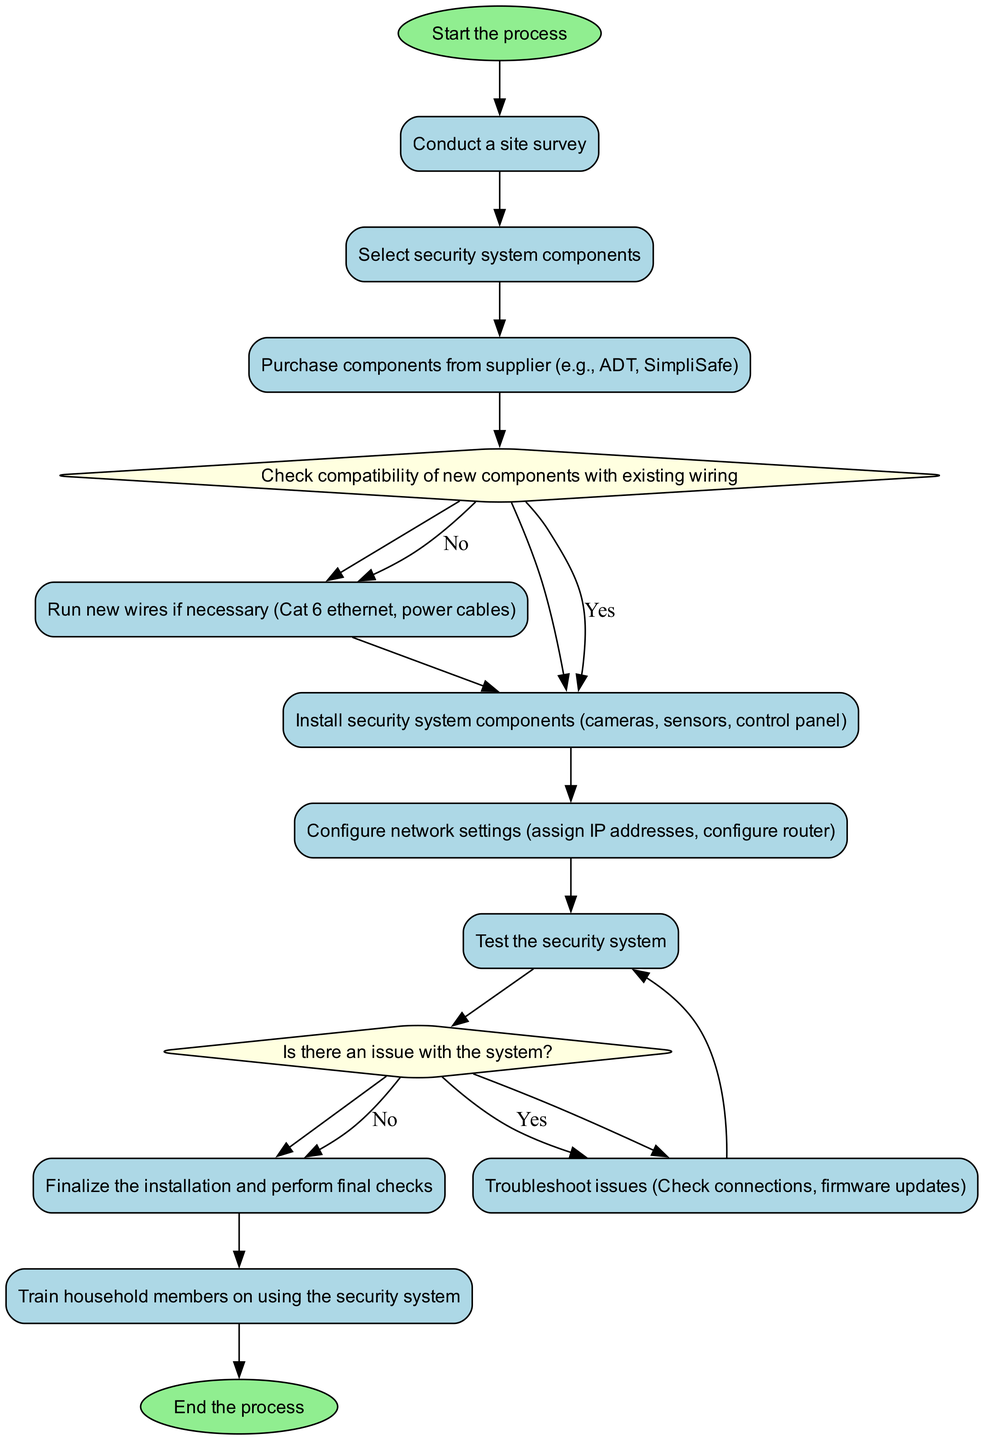What is the starting point of the flowchart? The flowchart begins with the "Start the process" node, labeled as "start". It serves as the entry point to the entire process of purchasing and installing a home security system.
Answer: Start the process How many decision nodes are present in the diagram? The diagram includes two decision nodes: "Check compatibility of new components with existing wiring" and "Is there an issue with the system?" This can be counted by identifying nodes with the type "decision" in the diagram.
Answer: 2 What process follows after the "Test the security system" node? After testing the system, the flowchart leads to the decision node "Is there an issue with the system?" This indicates the next step the user will review based on the testing outcome.
Answer: Is there an issue with the system? Which components are installed in the process? The installation process includes components such as cameras, sensors, and the control panel. This information is derived from the node labeled "Install security system components".
Answer: Cameras, sensors, control panel What action is taken if there is an issue detected with the system? If an issue is detected, the flowchart directs to the "Troubleshoot issues" process. The decision node clearly indicates that troubleshooting follows when problems arise after testing.
Answer: Troubleshoot issues What happens if the new components are compatible? If the new components are compatible with the existing wiring, the flowchart indicates moving to the "Install security system components" process. This is captured in the decision node leading to the installation step.
Answer: Install security system components Which node is the final step in the flowchart? The last node of the flowchart is labeled "End the process". It signifies the completion of the entire flow and marks where the process concludes.
Answer: End the process What is the purpose of the "Train household members on using the security system" process? The purpose of this process is to ensure that all household members understand how to properly use the newly installed security system. It is a crucial step to maximize the effectiveness of the system.
Answer: Understanding usage What type of wiring is mentioned in the flowchart for new installations? The flowchart specifies that "Run new wires if necessary" for Cat 6 Ethernet and power cables. This denotes the type of wiring that may need to be installed based on compatibility checks.
Answer: Cat 6 Ethernet, power cables 